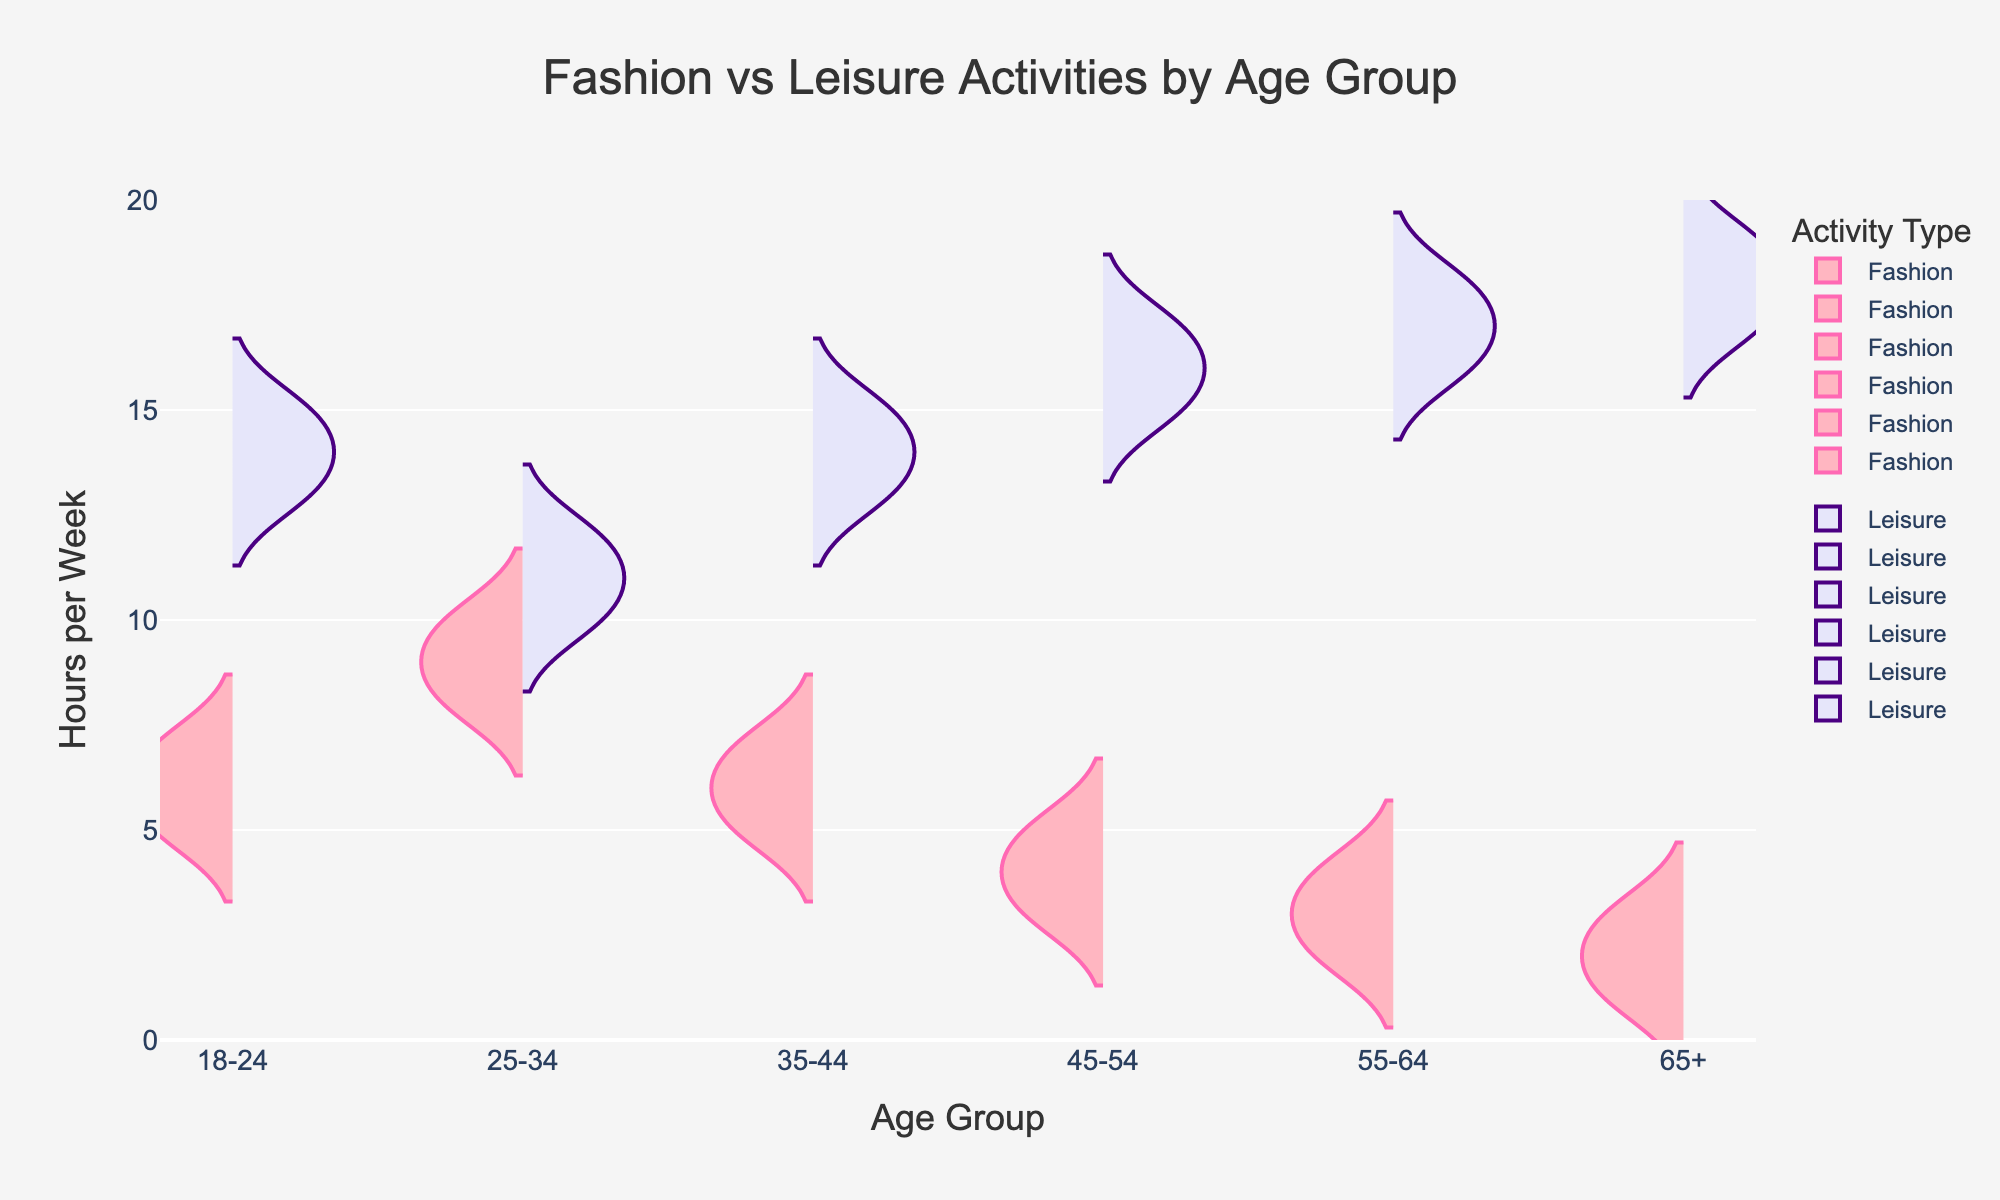What is the title of the chart? The title is located at the top of the chart in a larger font size meant to capture the viewer's attention and summarize the content of the plot. It reads "Fashion vs Leisure Activities by Age Group".
Answer: Fashion vs Leisure Activities by Age Group What is represented on the y-axis of the chart? The y-axis on the chart is labeled "Hours per Week", indicating that it measures the amount of time spent on fashion and leisure activities on a weekly basis.
Answer: Hours per Week Which age group spends the highest median hours on fashion activities per week? To determine the median, find the middle value of fashion activity hours for each age group. For 25-34 (values: 8, 9, 10), the median is 9 hours, which is the highest among all groups.
Answer: 25-34 How does the leisure activity time compare between the 18-24 and 65+ age groups? Compare the median values of leisure activity times between the two age groups: the 18-24 group has medians around 14-15 hours, while the 65+ group has medians around 17-18 hours. The 65+ group spends more time.
Answer: The 65+ age group spends more time What age group has the most symmetrical distribution of time spent on leisure activities? Examine the shape of the leisure activity violins for each age group. The 18-24 age group's distribution appears the most symmetrical, with a nearly even spread of data points around the center.
Answer: 18-24 What is the range of hours spent on fashion activities for the 35-44 age group? The fashion activity values for the 35-44 age group are 5, 6, and 7 hours. The range is found by subtracting the smallest value from the largest: 7 - 5 = 2 hours.
Answer: 2 hours Which age group shows the smallest difference in median hours between fashion and leisure activities? Calculate the median hours for both activities and then find the difference for each age group. The group with the smallest absolute difference is 25-34, where the difference is 9 (fashion) - 11 (leisure) = 2 hours.
Answer: 25-34 Do hours spent on fashion activities increase, decrease, or stay the same with age? Observe the trend of the median hours for fashion activities across age groups. The hours decrease with increasing age, starting higher in younger groups and dropping in older groups.
Answer: Decrease In which age group is there the widest variation in leisure activity hours? The variation can be judged by the spread of the leisure activity violin plots. The 45-54 and 55-64 age groups have a wide spread, but 55-64 appears to have a slightly wider range.
Answer: 55-64 